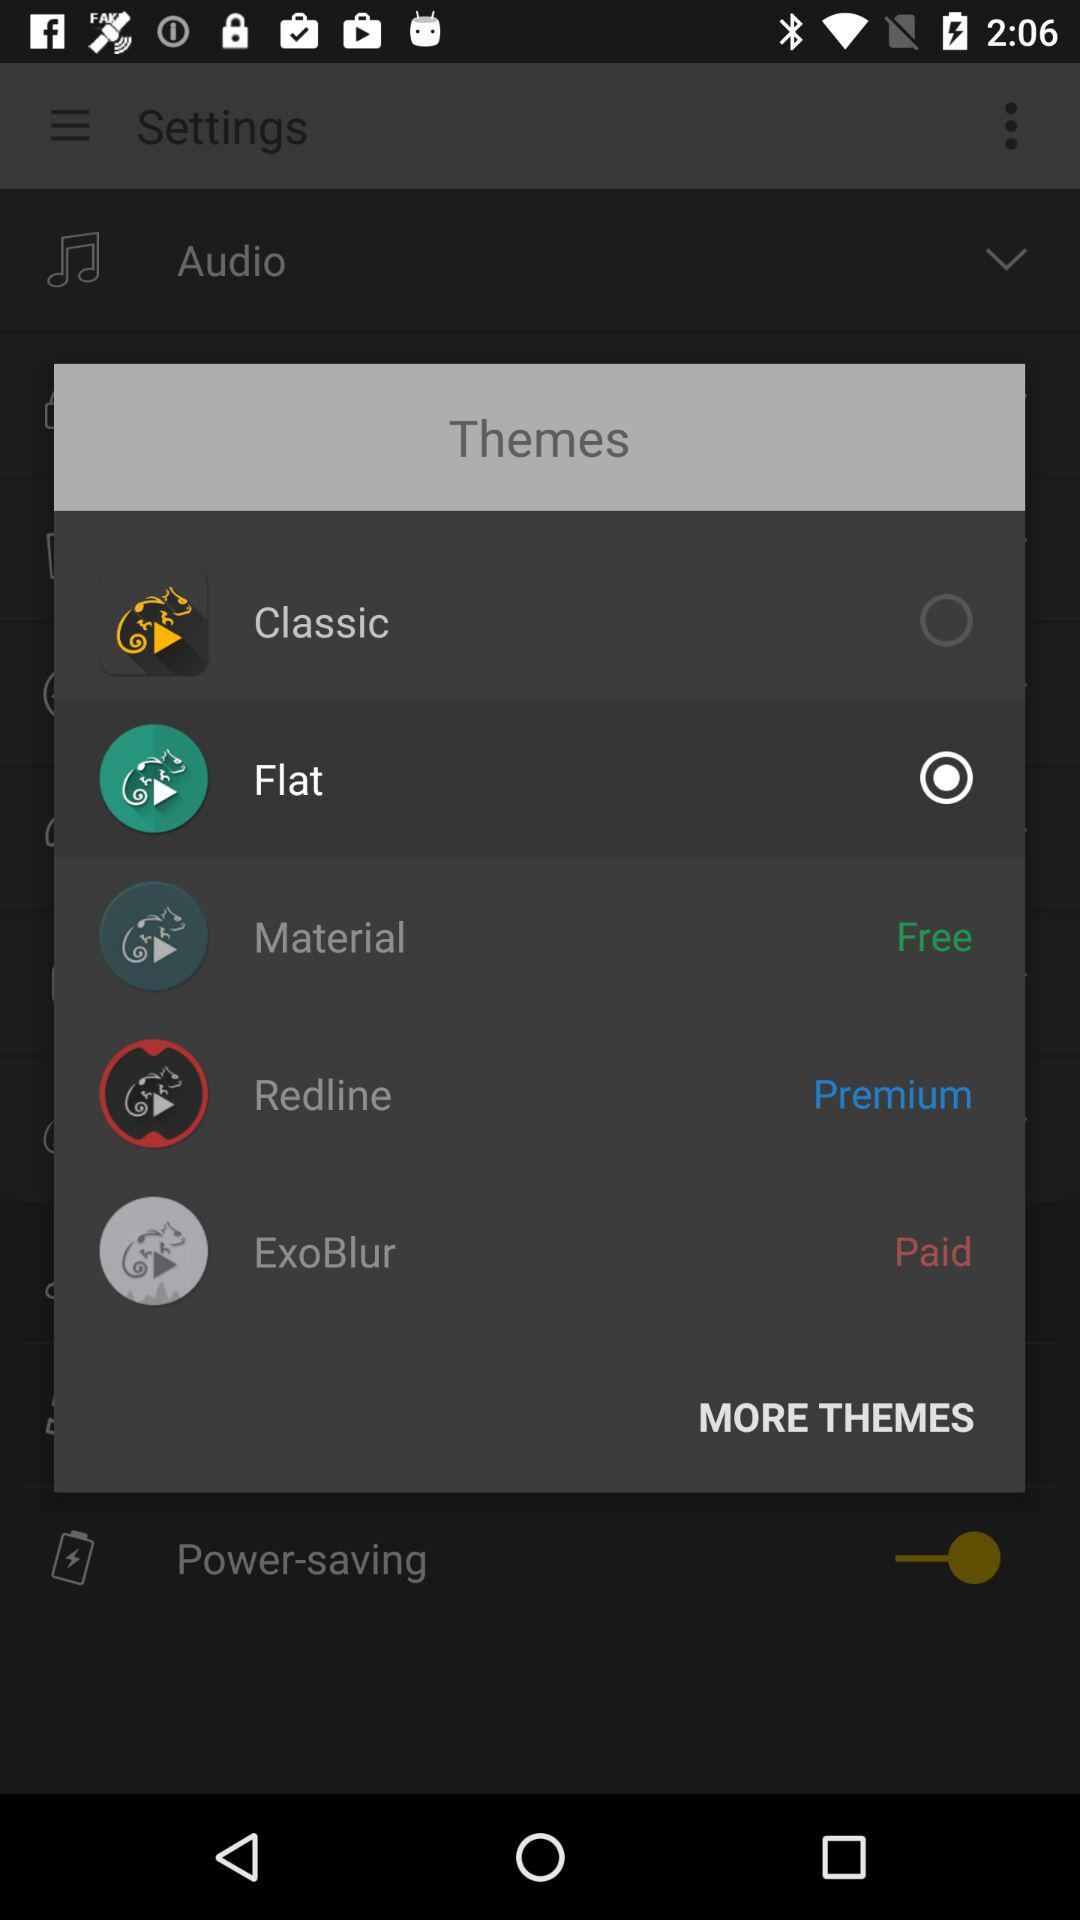How many themes are there in total?
Answer the question using a single word or phrase. 5 